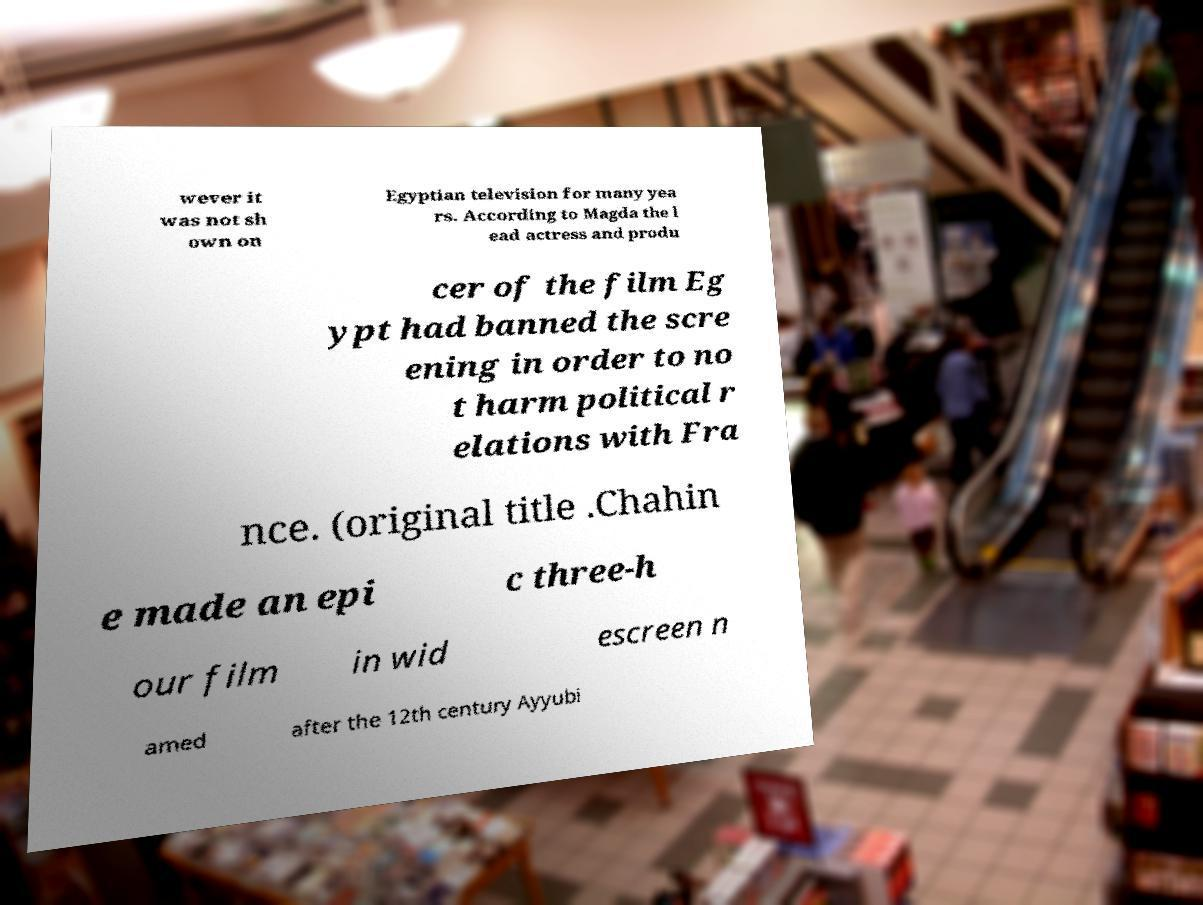Please read and relay the text visible in this image. What does it say? wever it was not sh own on Egyptian television for many yea rs. According to Magda the l ead actress and produ cer of the film Eg ypt had banned the scre ening in order to no t harm political r elations with Fra nce. (original title .Chahin e made an epi c three-h our film in wid escreen n amed after the 12th century Ayyubi 